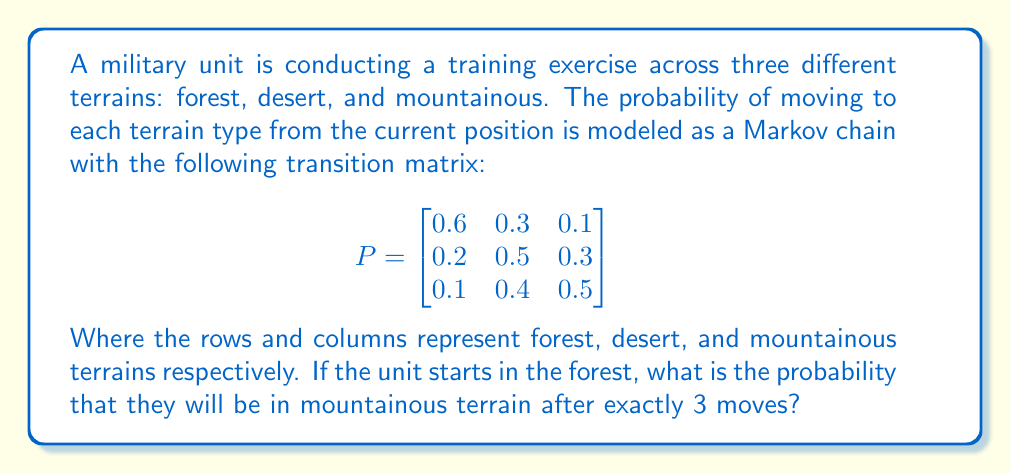Provide a solution to this math problem. To solve this problem, we need to use the Chapman-Kolmogorov equations and calculate the 3-step transition probability. Let's approach this step-by-step:

1) We start in the forest, which corresponds to the first row of the transition matrix.

2) To find the probability after 3 moves, we need to calculate $P^3$.

3) We can do this by multiplying P by itself three times:

   $$P^3 = P \times P \times P$$

4) Let's perform this multiplication:

   $$P^2 = \begin{bmatrix}
   0.6 & 0.3 & 0.1 \\
   0.2 & 0.5 & 0.3 \\
   0.1 & 0.4 & 0.5
   \end{bmatrix} \times \begin{bmatrix}
   0.6 & 0.3 & 0.1 \\
   0.2 & 0.5 & 0.3 \\
   0.1 & 0.4 & 0.5
   \end{bmatrix} = \begin{bmatrix}
   0.44 & 0.36 & 0.20 \\
   0.29 & 0.44 & 0.27 \\
   0.21 & 0.43 & 0.36
   \end{bmatrix}$$

5) Now, we multiply $P^2$ by P:

   $$P^3 = \begin{bmatrix}
   0.44 & 0.36 & 0.20 \\
   0.29 & 0.44 & 0.27 \\
   0.21 & 0.43 & 0.36
   \end{bmatrix} \times \begin{bmatrix}
   0.6 & 0.3 & 0.1 \\
   0.2 & 0.5 & 0.3 \\
   0.1 & 0.4 & 0.5
   \end{bmatrix} = \begin{bmatrix}
   0.374 & 0.378 & 0.248 \\
   0.317 & 0.411 & 0.272 \\
   0.263 & 0.424 & 0.313
   \end{bmatrix}$$

6) The probability of being in mountainous terrain after 3 moves, starting from the forest, is given by the element in the first row, third column of $P^3$.

Therefore, the probability is 0.248 or 24.8%.
Answer: 0.248 